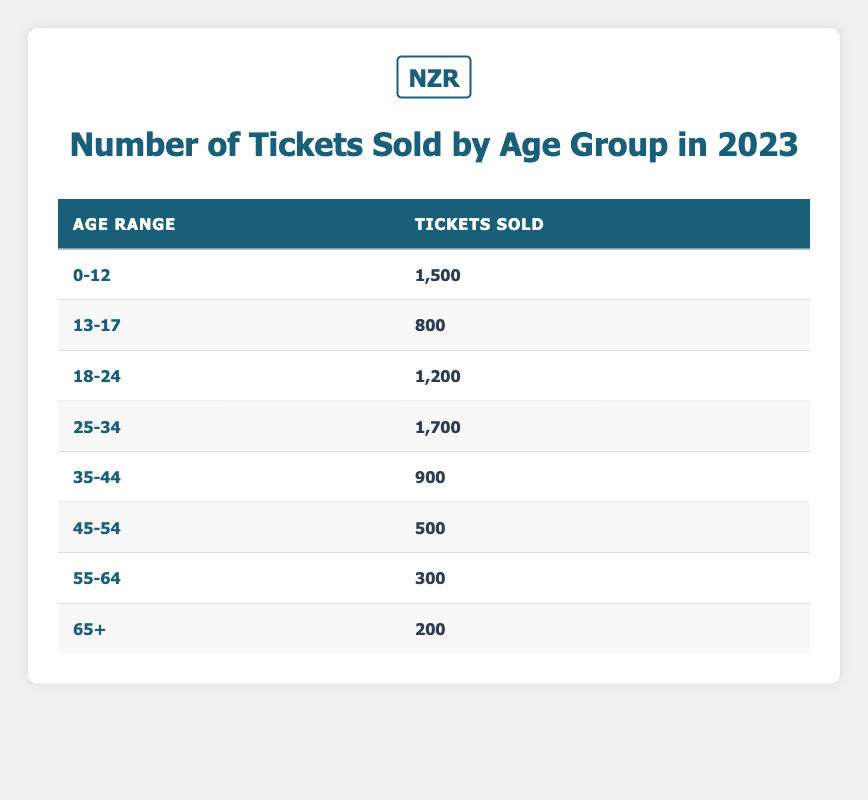What is the total number of tickets sold for the age group 25-34? The table states that 1,700 tickets were sold for the age group 25-34.
Answer: 1,700 Which age group sold the least number of tickets? The age group with the lowest number of tickets sold is 65+, with only 200 tickets sold.
Answer: 65+ What is the sum of tickets sold for the age groups 0-12 and 55-64? The tickets sold for age group 0-12 is 1,500 and for 55-64 is 300. Adding these gives 1,500 + 300 = 1,800.
Answer: 1,800 How many tickets were sold to individuals aged 35-44 compared to those aged 45-54? For age group 35-44, 900 tickets were sold, while for 45-54, 500 tickets were sold. The difference is 900 - 500 = 400.
Answer: 400 Is it true that more tickets were sold to the age group 18-24 than to the age group 45-54? Yes, 1,200 tickets were sold to the age group 18-24, which is greater than the 500 tickets sold to the age group 45-54.
Answer: Yes What is the average number of tickets sold across all age groups? To find the average, sum the total tickets sold across all groups: 1,500 + 800 + 1,200 + 1,700 + 900 + 500 + 300 + 200 = 6,100. There are 8 age groups, so the average is 6,100 / 8 = 762.5.
Answer: 762.5 How many more tickets were sold in the age group 25-34 than in the age group 13-17? For age group 25-34, 1,700 tickets were sold, and for 13-17, 800 tickets were sold. The difference is 1,700 - 800 = 900.
Answer: 900 What percentage of tickets sold were for the age group 55-64? The total tickets sold is 6,100. The age group 55-64 had 300 tickets sold. The percentage is (300 / 6,100) * 100, which calculates to approximately 4.92%.
Answer: 4.92% 